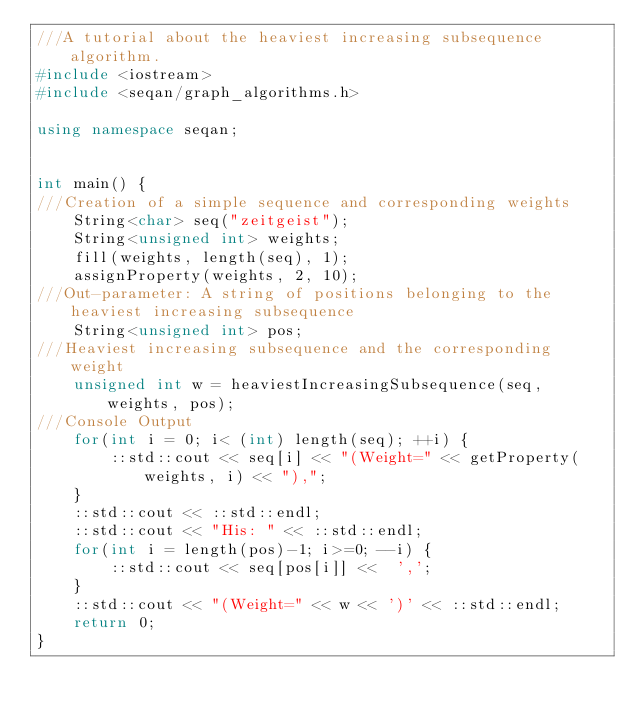<code> <loc_0><loc_0><loc_500><loc_500><_C++_>///A tutorial about the heaviest increasing subsequence algorithm.
#include <iostream>
#include <seqan/graph_algorithms.h>

using namespace seqan;


int main() {
///Creation of a simple sequence and corresponding weights
	String<char> seq("zeitgeist");
	String<unsigned int> weights;
	fill(weights, length(seq), 1);
	assignProperty(weights, 2, 10);
///Out-parameter: A string of positions belonging to the heaviest increasing subsequence
	String<unsigned int> pos;
///Heaviest increasing subsequence and the corresponding weight
	unsigned int w = heaviestIncreasingSubsequence(seq, weights, pos);
///Console Output
	for(int i = 0; i< (int) length(seq); ++i) {
		::std::cout << seq[i] << "(Weight=" << getProperty(weights, i) << "),";
	}
	::std::cout << ::std::endl;
	::std::cout << "His: " << ::std::endl;
	for(int i = length(pos)-1; i>=0; --i) {
		::std::cout << seq[pos[i]] <<  ',';
	}
	::std::cout << "(Weight=" << w << ')' << ::std::endl;
	return 0;
}
</code> 